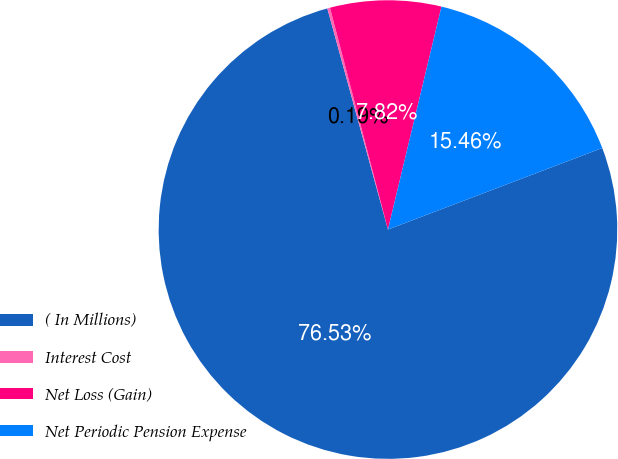Convert chart to OTSL. <chart><loc_0><loc_0><loc_500><loc_500><pie_chart><fcel>( In Millions)<fcel>Interest Cost<fcel>Net Loss (Gain)<fcel>Net Periodic Pension Expense<nl><fcel>76.53%<fcel>0.19%<fcel>7.82%<fcel>15.46%<nl></chart> 